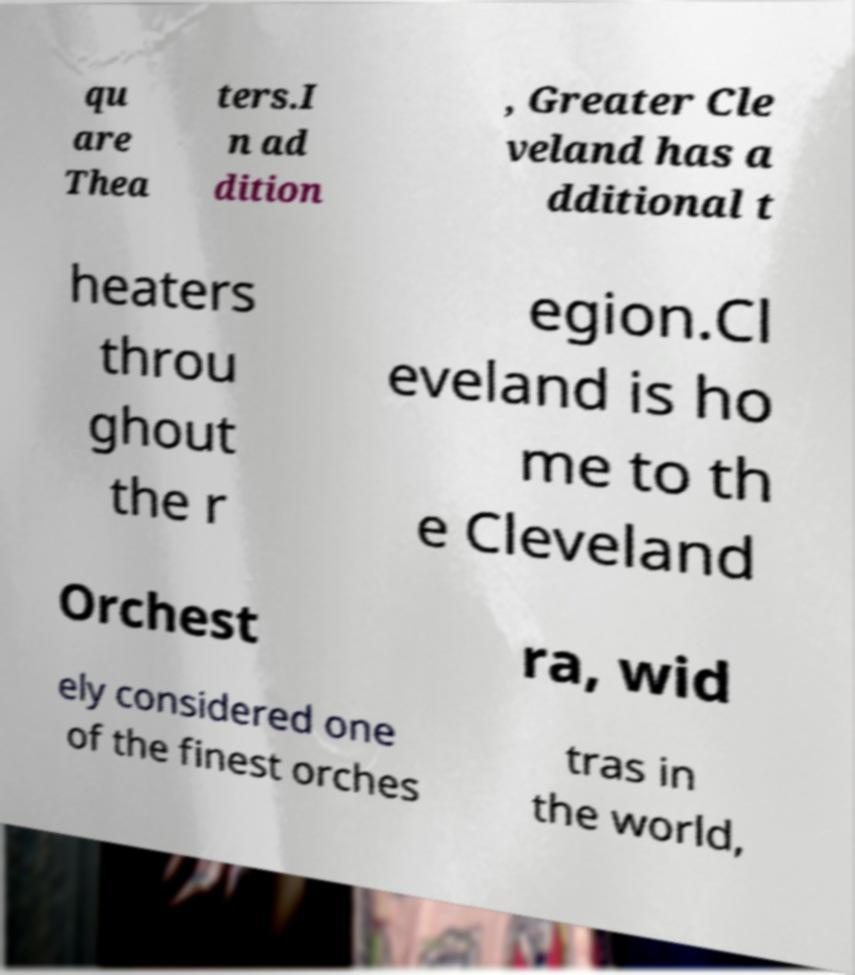Please read and relay the text visible in this image. What does it say? qu are Thea ters.I n ad dition , Greater Cle veland has a dditional t heaters throu ghout the r egion.Cl eveland is ho me to th e Cleveland Orchest ra, wid ely considered one of the finest orches tras in the world, 